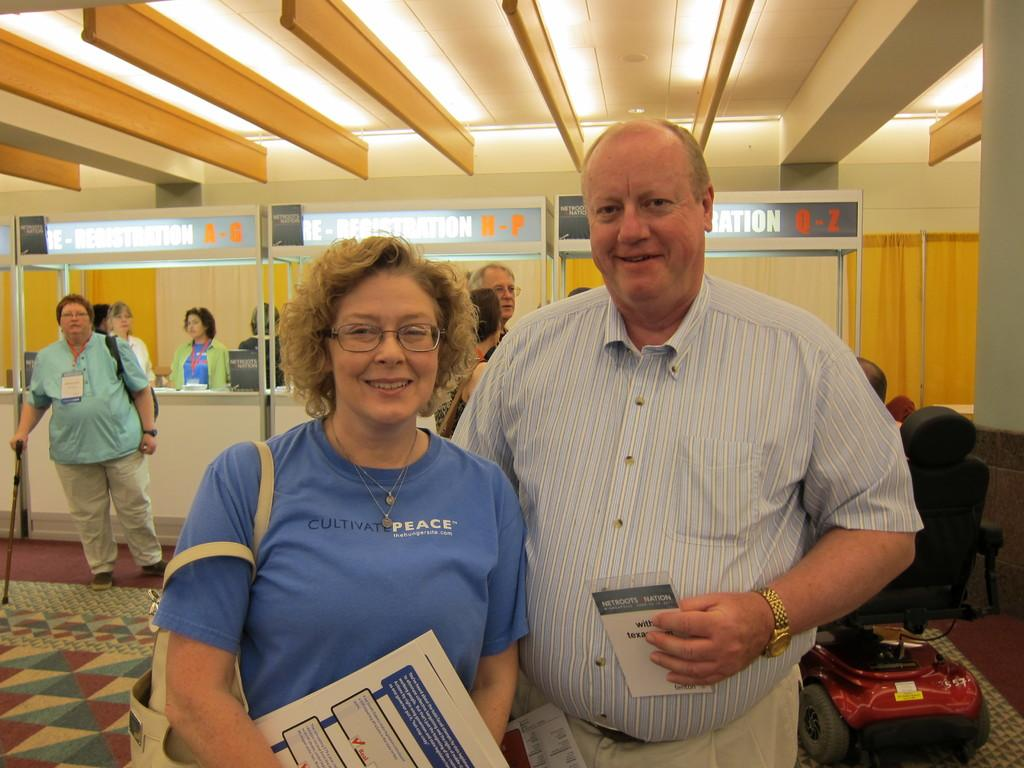What can be seen in the image? There are people standing in the image. Where are the people standing? The people are standing on a floor. What else can be seen in the background of the image? There is a wheelchair and a wall in the background of the image. What is visible at the top of the image? The ceiling is visible at the top of the image, and there are lights on the ceiling. What is the people writing in the image? There is no writing activity depicted in the image; the people are simply standing. 